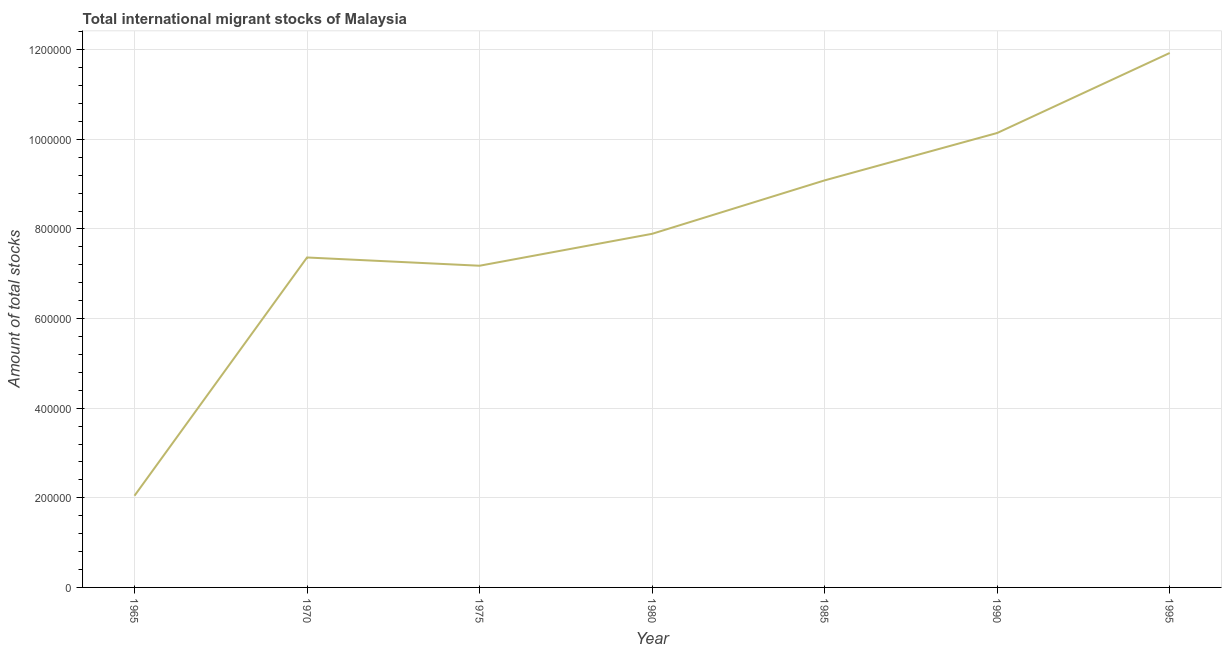What is the total number of international migrant stock in 1985?
Provide a succinct answer. 9.08e+05. Across all years, what is the maximum total number of international migrant stock?
Provide a short and direct response. 1.19e+06. Across all years, what is the minimum total number of international migrant stock?
Ensure brevity in your answer.  2.05e+05. In which year was the total number of international migrant stock minimum?
Provide a succinct answer. 1965. What is the sum of the total number of international migrant stock?
Offer a terse response. 5.56e+06. What is the difference between the total number of international migrant stock in 1965 and 1980?
Keep it short and to the point. -5.84e+05. What is the average total number of international migrant stock per year?
Provide a succinct answer. 7.95e+05. What is the median total number of international migrant stock?
Your answer should be compact. 7.89e+05. In how many years, is the total number of international migrant stock greater than 1080000 ?
Keep it short and to the point. 1. What is the ratio of the total number of international migrant stock in 1965 to that in 1985?
Provide a short and direct response. 0.23. Is the total number of international migrant stock in 1965 less than that in 1970?
Provide a succinct answer. Yes. Is the difference between the total number of international migrant stock in 1970 and 1990 greater than the difference between any two years?
Offer a terse response. No. What is the difference between the highest and the second highest total number of international migrant stock?
Provide a succinct answer. 1.79e+05. What is the difference between the highest and the lowest total number of international migrant stock?
Offer a terse response. 9.88e+05. Does the total number of international migrant stock monotonically increase over the years?
Offer a very short reply. No. How many years are there in the graph?
Your answer should be very brief. 7. What is the difference between two consecutive major ticks on the Y-axis?
Provide a short and direct response. 2.00e+05. Are the values on the major ticks of Y-axis written in scientific E-notation?
Offer a terse response. No. Does the graph contain any zero values?
Provide a short and direct response. No. Does the graph contain grids?
Offer a very short reply. Yes. What is the title of the graph?
Provide a succinct answer. Total international migrant stocks of Malaysia. What is the label or title of the X-axis?
Offer a very short reply. Year. What is the label or title of the Y-axis?
Your answer should be very brief. Amount of total stocks. What is the Amount of total stocks in 1965?
Offer a terse response. 2.05e+05. What is the Amount of total stocks of 1970?
Offer a terse response. 7.36e+05. What is the Amount of total stocks of 1975?
Provide a succinct answer. 7.18e+05. What is the Amount of total stocks in 1980?
Make the answer very short. 7.89e+05. What is the Amount of total stocks of 1985?
Offer a very short reply. 9.08e+05. What is the Amount of total stocks in 1990?
Provide a succinct answer. 1.01e+06. What is the Amount of total stocks of 1995?
Give a very brief answer. 1.19e+06. What is the difference between the Amount of total stocks in 1965 and 1970?
Keep it short and to the point. -5.32e+05. What is the difference between the Amount of total stocks in 1965 and 1975?
Ensure brevity in your answer.  -5.13e+05. What is the difference between the Amount of total stocks in 1965 and 1980?
Offer a terse response. -5.84e+05. What is the difference between the Amount of total stocks in 1965 and 1985?
Keep it short and to the point. -7.04e+05. What is the difference between the Amount of total stocks in 1965 and 1990?
Keep it short and to the point. -8.09e+05. What is the difference between the Amount of total stocks in 1965 and 1995?
Your answer should be very brief. -9.88e+05. What is the difference between the Amount of total stocks in 1970 and 1975?
Provide a succinct answer. 1.84e+04. What is the difference between the Amount of total stocks in 1970 and 1980?
Ensure brevity in your answer.  -5.28e+04. What is the difference between the Amount of total stocks in 1970 and 1985?
Give a very brief answer. -1.72e+05. What is the difference between the Amount of total stocks in 1970 and 1990?
Your answer should be very brief. -2.78e+05. What is the difference between the Amount of total stocks in 1970 and 1995?
Make the answer very short. -4.56e+05. What is the difference between the Amount of total stocks in 1975 and 1980?
Ensure brevity in your answer.  -7.12e+04. What is the difference between the Amount of total stocks in 1975 and 1985?
Keep it short and to the point. -1.90e+05. What is the difference between the Amount of total stocks in 1975 and 1990?
Give a very brief answer. -2.96e+05. What is the difference between the Amount of total stocks in 1975 and 1995?
Your response must be concise. -4.75e+05. What is the difference between the Amount of total stocks in 1980 and 1985?
Provide a succinct answer. -1.19e+05. What is the difference between the Amount of total stocks in 1980 and 1990?
Ensure brevity in your answer.  -2.25e+05. What is the difference between the Amount of total stocks in 1980 and 1995?
Your answer should be very brief. -4.04e+05. What is the difference between the Amount of total stocks in 1985 and 1990?
Provide a short and direct response. -1.06e+05. What is the difference between the Amount of total stocks in 1985 and 1995?
Keep it short and to the point. -2.84e+05. What is the difference between the Amount of total stocks in 1990 and 1995?
Your response must be concise. -1.79e+05. What is the ratio of the Amount of total stocks in 1965 to that in 1970?
Your answer should be very brief. 0.28. What is the ratio of the Amount of total stocks in 1965 to that in 1975?
Give a very brief answer. 0.28. What is the ratio of the Amount of total stocks in 1965 to that in 1980?
Give a very brief answer. 0.26. What is the ratio of the Amount of total stocks in 1965 to that in 1985?
Offer a very short reply. 0.23. What is the ratio of the Amount of total stocks in 1965 to that in 1990?
Ensure brevity in your answer.  0.2. What is the ratio of the Amount of total stocks in 1965 to that in 1995?
Provide a succinct answer. 0.17. What is the ratio of the Amount of total stocks in 1970 to that in 1975?
Provide a short and direct response. 1.03. What is the ratio of the Amount of total stocks in 1970 to that in 1980?
Provide a short and direct response. 0.93. What is the ratio of the Amount of total stocks in 1970 to that in 1985?
Ensure brevity in your answer.  0.81. What is the ratio of the Amount of total stocks in 1970 to that in 1990?
Your answer should be very brief. 0.73. What is the ratio of the Amount of total stocks in 1970 to that in 1995?
Offer a very short reply. 0.62. What is the ratio of the Amount of total stocks in 1975 to that in 1980?
Your answer should be very brief. 0.91. What is the ratio of the Amount of total stocks in 1975 to that in 1985?
Your response must be concise. 0.79. What is the ratio of the Amount of total stocks in 1975 to that in 1990?
Offer a terse response. 0.71. What is the ratio of the Amount of total stocks in 1975 to that in 1995?
Your response must be concise. 0.6. What is the ratio of the Amount of total stocks in 1980 to that in 1985?
Ensure brevity in your answer.  0.87. What is the ratio of the Amount of total stocks in 1980 to that in 1990?
Make the answer very short. 0.78. What is the ratio of the Amount of total stocks in 1980 to that in 1995?
Your answer should be compact. 0.66. What is the ratio of the Amount of total stocks in 1985 to that in 1990?
Give a very brief answer. 0.9. What is the ratio of the Amount of total stocks in 1985 to that in 1995?
Your answer should be compact. 0.76. What is the ratio of the Amount of total stocks in 1990 to that in 1995?
Provide a succinct answer. 0.85. 